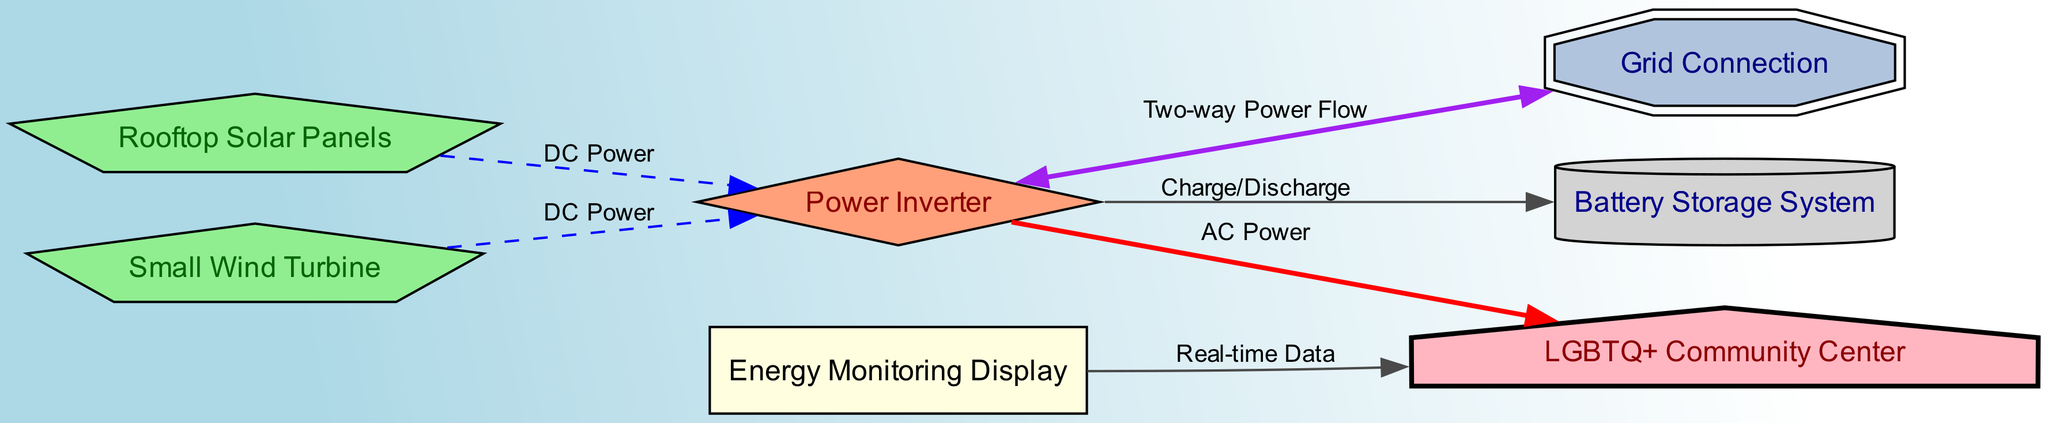What are the two power sources connected to the inverter? The diagram shows two sources: Rooftop Solar Panels and Small Wind Turbine, both transferring DC Power to the Power Inverter.
Answer: Rooftop Solar Panels, Small Wind Turbine How many nodes are there in total? The diagram specifies 7 nodes connected in various ways, including the community center and renewable energy components.
Answer: 7 What type of display is connected to the community center? The Energy Monitoring Display is linked to the community center, providing real-time data about energy use.
Answer: Energy Monitoring Display What type of power flow exists between the inverter and the grid connection? The diagram indicates a Two-way Power Flow, allowing electricity to be sent to and received from the grid, emphasizing the inverter's dual function.
Answer: Two-way Power Flow Which component stores energy generated from solar panels and wind turbines? The Battery Storage System is responsible for storing the energy generated, allowing for better energy management for the community center.
Answer: Battery Storage System What type of power do the solar panels and wind turbine provide to the inverter? Both the solar panels and wind turbine supply DC Power to the inverter for conversion to AC Power to serve the community center.
Answer: DC Power How do the inverter and battery storage system interact? The inverter facilitates Charge/Discharge between itself and the battery storage system to manage energy storage effectively.
Answer: Charge/Discharge What color represents the community center in the diagram? The community center is depicted with a light pink color and a house shape, highlighting its importance within the renewable energy system.
Answer: Light pink What is the role of the energy monitoring display? The Energy Monitoring Display provides real-time data to the community center, allowing the community to stay informed about their energy usage and production.
Answer: Real-time Data 